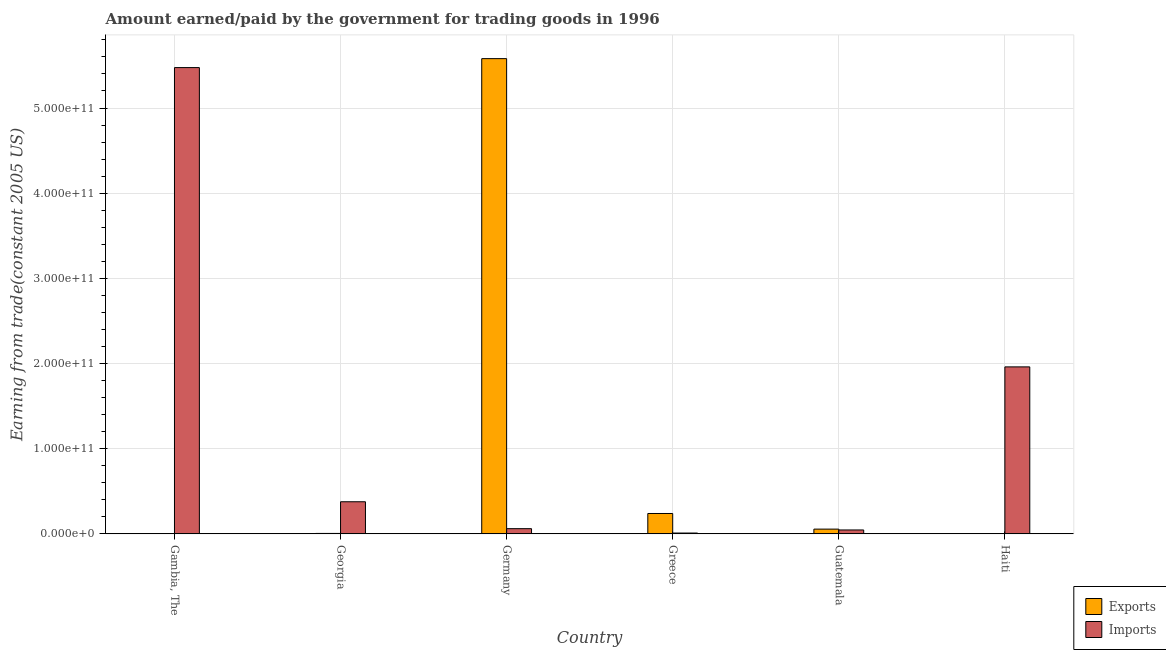How many different coloured bars are there?
Your response must be concise. 2. How many groups of bars are there?
Give a very brief answer. 6. How many bars are there on the 2nd tick from the left?
Keep it short and to the point. 2. What is the label of the 3rd group of bars from the left?
Your answer should be very brief. Germany. In how many cases, is the number of bars for a given country not equal to the number of legend labels?
Keep it short and to the point. 0. What is the amount earned from exports in Gambia, The?
Ensure brevity in your answer.  1.70e+08. Across all countries, what is the maximum amount paid for imports?
Your answer should be compact. 5.47e+11. Across all countries, what is the minimum amount paid for imports?
Provide a succinct answer. 9.69e+08. In which country was the amount paid for imports maximum?
Provide a succinct answer. Gambia, The. In which country was the amount earned from exports minimum?
Keep it short and to the point. Gambia, The. What is the total amount earned from exports in the graph?
Provide a succinct answer. 5.88e+11. What is the difference between the amount earned from exports in Gambia, The and that in Georgia?
Ensure brevity in your answer.  -3.33e+08. What is the difference between the amount earned from exports in Haiti and the amount paid for imports in Georgia?
Make the answer very short. -3.74e+1. What is the average amount earned from exports per country?
Give a very brief answer. 9.81e+1. What is the difference between the amount paid for imports and amount earned from exports in Gambia, The?
Make the answer very short. 5.47e+11. In how many countries, is the amount earned from exports greater than 520000000000 US$?
Ensure brevity in your answer.  1. What is the ratio of the amount earned from exports in Germany to that in Greece?
Ensure brevity in your answer.  23.32. What is the difference between the highest and the second highest amount paid for imports?
Your answer should be very brief. 3.51e+11. What is the difference between the highest and the lowest amount paid for imports?
Ensure brevity in your answer.  5.47e+11. Is the sum of the amount earned from exports in Germany and Haiti greater than the maximum amount paid for imports across all countries?
Keep it short and to the point. Yes. What does the 2nd bar from the left in Gambia, The represents?
Provide a short and direct response. Imports. What does the 2nd bar from the right in Haiti represents?
Provide a succinct answer. Exports. How many bars are there?
Make the answer very short. 12. Are all the bars in the graph horizontal?
Provide a succinct answer. No. How many countries are there in the graph?
Provide a succinct answer. 6. What is the difference between two consecutive major ticks on the Y-axis?
Provide a succinct answer. 1.00e+11. Does the graph contain any zero values?
Ensure brevity in your answer.  No. Does the graph contain grids?
Provide a succinct answer. Yes. Where does the legend appear in the graph?
Offer a very short reply. Bottom right. What is the title of the graph?
Ensure brevity in your answer.  Amount earned/paid by the government for trading goods in 1996. Does "Highest 10% of population" appear as one of the legend labels in the graph?
Your answer should be compact. No. What is the label or title of the X-axis?
Give a very brief answer. Country. What is the label or title of the Y-axis?
Your answer should be very brief. Earning from trade(constant 2005 US). What is the Earning from trade(constant 2005 US) in Exports in Gambia, The?
Ensure brevity in your answer.  1.70e+08. What is the Earning from trade(constant 2005 US) in Imports in Gambia, The?
Keep it short and to the point. 5.47e+11. What is the Earning from trade(constant 2005 US) in Exports in Georgia?
Keep it short and to the point. 5.02e+08. What is the Earning from trade(constant 2005 US) of Imports in Georgia?
Your answer should be very brief. 3.77e+1. What is the Earning from trade(constant 2005 US) in Exports in Germany?
Make the answer very short. 5.58e+11. What is the Earning from trade(constant 2005 US) in Imports in Germany?
Give a very brief answer. 6.09e+09. What is the Earning from trade(constant 2005 US) of Exports in Greece?
Offer a terse response. 2.39e+1. What is the Earning from trade(constant 2005 US) of Imports in Greece?
Offer a very short reply. 9.69e+08. What is the Earning from trade(constant 2005 US) of Exports in Guatemala?
Your answer should be compact. 5.57e+09. What is the Earning from trade(constant 2005 US) in Imports in Guatemala?
Your answer should be very brief. 4.59e+09. What is the Earning from trade(constant 2005 US) in Exports in Haiti?
Provide a succinct answer. 3.08e+08. What is the Earning from trade(constant 2005 US) of Imports in Haiti?
Your answer should be very brief. 1.96e+11. Across all countries, what is the maximum Earning from trade(constant 2005 US) of Exports?
Your response must be concise. 5.58e+11. Across all countries, what is the maximum Earning from trade(constant 2005 US) in Imports?
Ensure brevity in your answer.  5.47e+11. Across all countries, what is the minimum Earning from trade(constant 2005 US) in Exports?
Provide a succinct answer. 1.70e+08. Across all countries, what is the minimum Earning from trade(constant 2005 US) of Imports?
Make the answer very short. 9.69e+08. What is the total Earning from trade(constant 2005 US) of Exports in the graph?
Ensure brevity in your answer.  5.88e+11. What is the total Earning from trade(constant 2005 US) in Imports in the graph?
Ensure brevity in your answer.  7.93e+11. What is the difference between the Earning from trade(constant 2005 US) in Exports in Gambia, The and that in Georgia?
Make the answer very short. -3.33e+08. What is the difference between the Earning from trade(constant 2005 US) in Imports in Gambia, The and that in Georgia?
Provide a succinct answer. 5.10e+11. What is the difference between the Earning from trade(constant 2005 US) in Exports in Gambia, The and that in Germany?
Give a very brief answer. -5.58e+11. What is the difference between the Earning from trade(constant 2005 US) of Imports in Gambia, The and that in Germany?
Your answer should be compact. 5.41e+11. What is the difference between the Earning from trade(constant 2005 US) in Exports in Gambia, The and that in Greece?
Provide a short and direct response. -2.38e+1. What is the difference between the Earning from trade(constant 2005 US) in Imports in Gambia, The and that in Greece?
Provide a succinct answer. 5.47e+11. What is the difference between the Earning from trade(constant 2005 US) of Exports in Gambia, The and that in Guatemala?
Give a very brief answer. -5.40e+09. What is the difference between the Earning from trade(constant 2005 US) of Imports in Gambia, The and that in Guatemala?
Offer a terse response. 5.43e+11. What is the difference between the Earning from trade(constant 2005 US) of Exports in Gambia, The and that in Haiti?
Provide a short and direct response. -1.38e+08. What is the difference between the Earning from trade(constant 2005 US) of Imports in Gambia, The and that in Haiti?
Provide a short and direct response. 3.51e+11. What is the difference between the Earning from trade(constant 2005 US) in Exports in Georgia and that in Germany?
Offer a terse response. -5.57e+11. What is the difference between the Earning from trade(constant 2005 US) of Imports in Georgia and that in Germany?
Offer a terse response. 3.16e+1. What is the difference between the Earning from trade(constant 2005 US) of Exports in Georgia and that in Greece?
Keep it short and to the point. -2.34e+1. What is the difference between the Earning from trade(constant 2005 US) in Imports in Georgia and that in Greece?
Give a very brief answer. 3.67e+1. What is the difference between the Earning from trade(constant 2005 US) in Exports in Georgia and that in Guatemala?
Your answer should be compact. -5.06e+09. What is the difference between the Earning from trade(constant 2005 US) in Imports in Georgia and that in Guatemala?
Ensure brevity in your answer.  3.31e+1. What is the difference between the Earning from trade(constant 2005 US) of Exports in Georgia and that in Haiti?
Give a very brief answer. 1.95e+08. What is the difference between the Earning from trade(constant 2005 US) in Imports in Georgia and that in Haiti?
Give a very brief answer. -1.58e+11. What is the difference between the Earning from trade(constant 2005 US) of Exports in Germany and that in Greece?
Offer a very short reply. 5.34e+11. What is the difference between the Earning from trade(constant 2005 US) of Imports in Germany and that in Greece?
Your answer should be compact. 5.13e+09. What is the difference between the Earning from trade(constant 2005 US) of Exports in Germany and that in Guatemala?
Offer a very short reply. 5.52e+11. What is the difference between the Earning from trade(constant 2005 US) of Imports in Germany and that in Guatemala?
Give a very brief answer. 1.51e+09. What is the difference between the Earning from trade(constant 2005 US) in Exports in Germany and that in Haiti?
Offer a very short reply. 5.58e+11. What is the difference between the Earning from trade(constant 2005 US) in Imports in Germany and that in Haiti?
Ensure brevity in your answer.  -1.90e+11. What is the difference between the Earning from trade(constant 2005 US) of Exports in Greece and that in Guatemala?
Your answer should be compact. 1.84e+1. What is the difference between the Earning from trade(constant 2005 US) in Imports in Greece and that in Guatemala?
Give a very brief answer. -3.62e+09. What is the difference between the Earning from trade(constant 2005 US) of Exports in Greece and that in Haiti?
Make the answer very short. 2.36e+1. What is the difference between the Earning from trade(constant 2005 US) of Imports in Greece and that in Haiti?
Provide a short and direct response. -1.95e+11. What is the difference between the Earning from trade(constant 2005 US) in Exports in Guatemala and that in Haiti?
Ensure brevity in your answer.  5.26e+09. What is the difference between the Earning from trade(constant 2005 US) in Imports in Guatemala and that in Haiti?
Your response must be concise. -1.91e+11. What is the difference between the Earning from trade(constant 2005 US) of Exports in Gambia, The and the Earning from trade(constant 2005 US) of Imports in Georgia?
Keep it short and to the point. -3.75e+1. What is the difference between the Earning from trade(constant 2005 US) of Exports in Gambia, The and the Earning from trade(constant 2005 US) of Imports in Germany?
Your answer should be very brief. -5.92e+09. What is the difference between the Earning from trade(constant 2005 US) of Exports in Gambia, The and the Earning from trade(constant 2005 US) of Imports in Greece?
Provide a succinct answer. -8.00e+08. What is the difference between the Earning from trade(constant 2005 US) of Exports in Gambia, The and the Earning from trade(constant 2005 US) of Imports in Guatemala?
Offer a terse response. -4.42e+09. What is the difference between the Earning from trade(constant 2005 US) of Exports in Gambia, The and the Earning from trade(constant 2005 US) of Imports in Haiti?
Offer a terse response. -1.96e+11. What is the difference between the Earning from trade(constant 2005 US) in Exports in Georgia and the Earning from trade(constant 2005 US) in Imports in Germany?
Provide a short and direct response. -5.59e+09. What is the difference between the Earning from trade(constant 2005 US) in Exports in Georgia and the Earning from trade(constant 2005 US) in Imports in Greece?
Your answer should be very brief. -4.67e+08. What is the difference between the Earning from trade(constant 2005 US) in Exports in Georgia and the Earning from trade(constant 2005 US) in Imports in Guatemala?
Give a very brief answer. -4.08e+09. What is the difference between the Earning from trade(constant 2005 US) in Exports in Georgia and the Earning from trade(constant 2005 US) in Imports in Haiti?
Offer a very short reply. -1.96e+11. What is the difference between the Earning from trade(constant 2005 US) of Exports in Germany and the Earning from trade(constant 2005 US) of Imports in Greece?
Your answer should be very brief. 5.57e+11. What is the difference between the Earning from trade(constant 2005 US) of Exports in Germany and the Earning from trade(constant 2005 US) of Imports in Guatemala?
Offer a terse response. 5.53e+11. What is the difference between the Earning from trade(constant 2005 US) of Exports in Germany and the Earning from trade(constant 2005 US) of Imports in Haiti?
Provide a succinct answer. 3.62e+11. What is the difference between the Earning from trade(constant 2005 US) in Exports in Greece and the Earning from trade(constant 2005 US) in Imports in Guatemala?
Keep it short and to the point. 1.93e+1. What is the difference between the Earning from trade(constant 2005 US) in Exports in Greece and the Earning from trade(constant 2005 US) in Imports in Haiti?
Keep it short and to the point. -1.72e+11. What is the difference between the Earning from trade(constant 2005 US) of Exports in Guatemala and the Earning from trade(constant 2005 US) of Imports in Haiti?
Offer a terse response. -1.90e+11. What is the average Earning from trade(constant 2005 US) in Exports per country?
Give a very brief answer. 9.81e+1. What is the average Earning from trade(constant 2005 US) of Imports per country?
Make the answer very short. 1.32e+11. What is the difference between the Earning from trade(constant 2005 US) of Exports and Earning from trade(constant 2005 US) of Imports in Gambia, The?
Give a very brief answer. -5.47e+11. What is the difference between the Earning from trade(constant 2005 US) of Exports and Earning from trade(constant 2005 US) of Imports in Georgia?
Provide a succinct answer. -3.72e+1. What is the difference between the Earning from trade(constant 2005 US) of Exports and Earning from trade(constant 2005 US) of Imports in Germany?
Provide a succinct answer. 5.52e+11. What is the difference between the Earning from trade(constant 2005 US) in Exports and Earning from trade(constant 2005 US) in Imports in Greece?
Give a very brief answer. 2.30e+1. What is the difference between the Earning from trade(constant 2005 US) in Exports and Earning from trade(constant 2005 US) in Imports in Guatemala?
Make the answer very short. 9.79e+08. What is the difference between the Earning from trade(constant 2005 US) of Exports and Earning from trade(constant 2005 US) of Imports in Haiti?
Provide a short and direct response. -1.96e+11. What is the ratio of the Earning from trade(constant 2005 US) in Exports in Gambia, The to that in Georgia?
Offer a terse response. 0.34. What is the ratio of the Earning from trade(constant 2005 US) in Imports in Gambia, The to that in Georgia?
Keep it short and to the point. 14.52. What is the ratio of the Earning from trade(constant 2005 US) of Exports in Gambia, The to that in Germany?
Keep it short and to the point. 0. What is the ratio of the Earning from trade(constant 2005 US) in Imports in Gambia, The to that in Germany?
Offer a terse response. 89.83. What is the ratio of the Earning from trade(constant 2005 US) in Exports in Gambia, The to that in Greece?
Your answer should be compact. 0.01. What is the ratio of the Earning from trade(constant 2005 US) of Imports in Gambia, The to that in Greece?
Offer a very short reply. 564.81. What is the ratio of the Earning from trade(constant 2005 US) of Exports in Gambia, The to that in Guatemala?
Ensure brevity in your answer.  0.03. What is the ratio of the Earning from trade(constant 2005 US) of Imports in Gambia, The to that in Guatemala?
Offer a terse response. 119.36. What is the ratio of the Earning from trade(constant 2005 US) in Exports in Gambia, The to that in Haiti?
Your answer should be compact. 0.55. What is the ratio of the Earning from trade(constant 2005 US) in Imports in Gambia, The to that in Haiti?
Keep it short and to the point. 2.79. What is the ratio of the Earning from trade(constant 2005 US) in Exports in Georgia to that in Germany?
Give a very brief answer. 0. What is the ratio of the Earning from trade(constant 2005 US) of Imports in Georgia to that in Germany?
Ensure brevity in your answer.  6.19. What is the ratio of the Earning from trade(constant 2005 US) of Exports in Georgia to that in Greece?
Ensure brevity in your answer.  0.02. What is the ratio of the Earning from trade(constant 2005 US) of Imports in Georgia to that in Greece?
Offer a very short reply. 38.9. What is the ratio of the Earning from trade(constant 2005 US) of Exports in Georgia to that in Guatemala?
Offer a very short reply. 0.09. What is the ratio of the Earning from trade(constant 2005 US) in Imports in Georgia to that in Guatemala?
Provide a short and direct response. 8.22. What is the ratio of the Earning from trade(constant 2005 US) of Exports in Georgia to that in Haiti?
Ensure brevity in your answer.  1.63. What is the ratio of the Earning from trade(constant 2005 US) in Imports in Georgia to that in Haiti?
Provide a short and direct response. 0.19. What is the ratio of the Earning from trade(constant 2005 US) of Exports in Germany to that in Greece?
Make the answer very short. 23.32. What is the ratio of the Earning from trade(constant 2005 US) in Imports in Germany to that in Greece?
Keep it short and to the point. 6.29. What is the ratio of the Earning from trade(constant 2005 US) of Exports in Germany to that in Guatemala?
Keep it short and to the point. 100.25. What is the ratio of the Earning from trade(constant 2005 US) in Imports in Germany to that in Guatemala?
Your response must be concise. 1.33. What is the ratio of the Earning from trade(constant 2005 US) in Exports in Germany to that in Haiti?
Your answer should be very brief. 1812.96. What is the ratio of the Earning from trade(constant 2005 US) of Imports in Germany to that in Haiti?
Offer a terse response. 0.03. What is the ratio of the Earning from trade(constant 2005 US) in Exports in Greece to that in Guatemala?
Ensure brevity in your answer.  4.3. What is the ratio of the Earning from trade(constant 2005 US) of Imports in Greece to that in Guatemala?
Your answer should be compact. 0.21. What is the ratio of the Earning from trade(constant 2005 US) of Exports in Greece to that in Haiti?
Keep it short and to the point. 77.73. What is the ratio of the Earning from trade(constant 2005 US) of Imports in Greece to that in Haiti?
Keep it short and to the point. 0. What is the ratio of the Earning from trade(constant 2005 US) of Exports in Guatemala to that in Haiti?
Your response must be concise. 18.08. What is the ratio of the Earning from trade(constant 2005 US) in Imports in Guatemala to that in Haiti?
Your response must be concise. 0.02. What is the difference between the highest and the second highest Earning from trade(constant 2005 US) in Exports?
Give a very brief answer. 5.34e+11. What is the difference between the highest and the second highest Earning from trade(constant 2005 US) of Imports?
Your answer should be compact. 3.51e+11. What is the difference between the highest and the lowest Earning from trade(constant 2005 US) of Exports?
Keep it short and to the point. 5.58e+11. What is the difference between the highest and the lowest Earning from trade(constant 2005 US) in Imports?
Offer a terse response. 5.47e+11. 